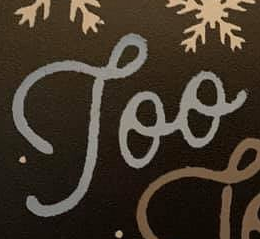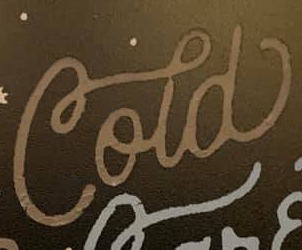Identify the words shown in these images in order, separated by a semicolon. Too; Cold 